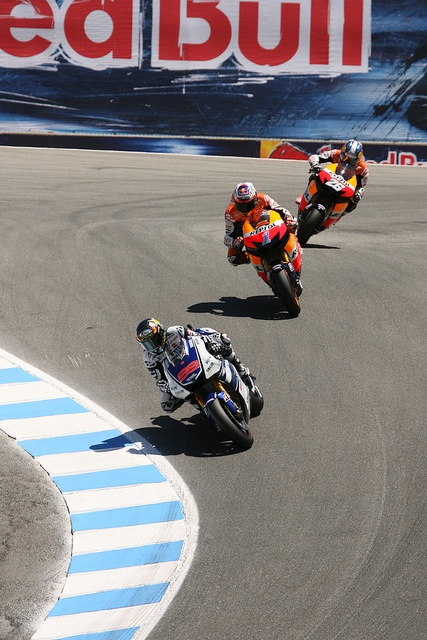Describe the objects in this image and their specific colors. I can see motorcycle in brown, black, lightgray, gray, and darkgray tones, motorcycle in brown, black, gray, and red tones, motorcycle in brown, black, maroon, gray, and darkgray tones, people in brown, black, gray, darkgray, and lightgray tones, and people in brown, black, maroon, gray, and lightgray tones in this image. 